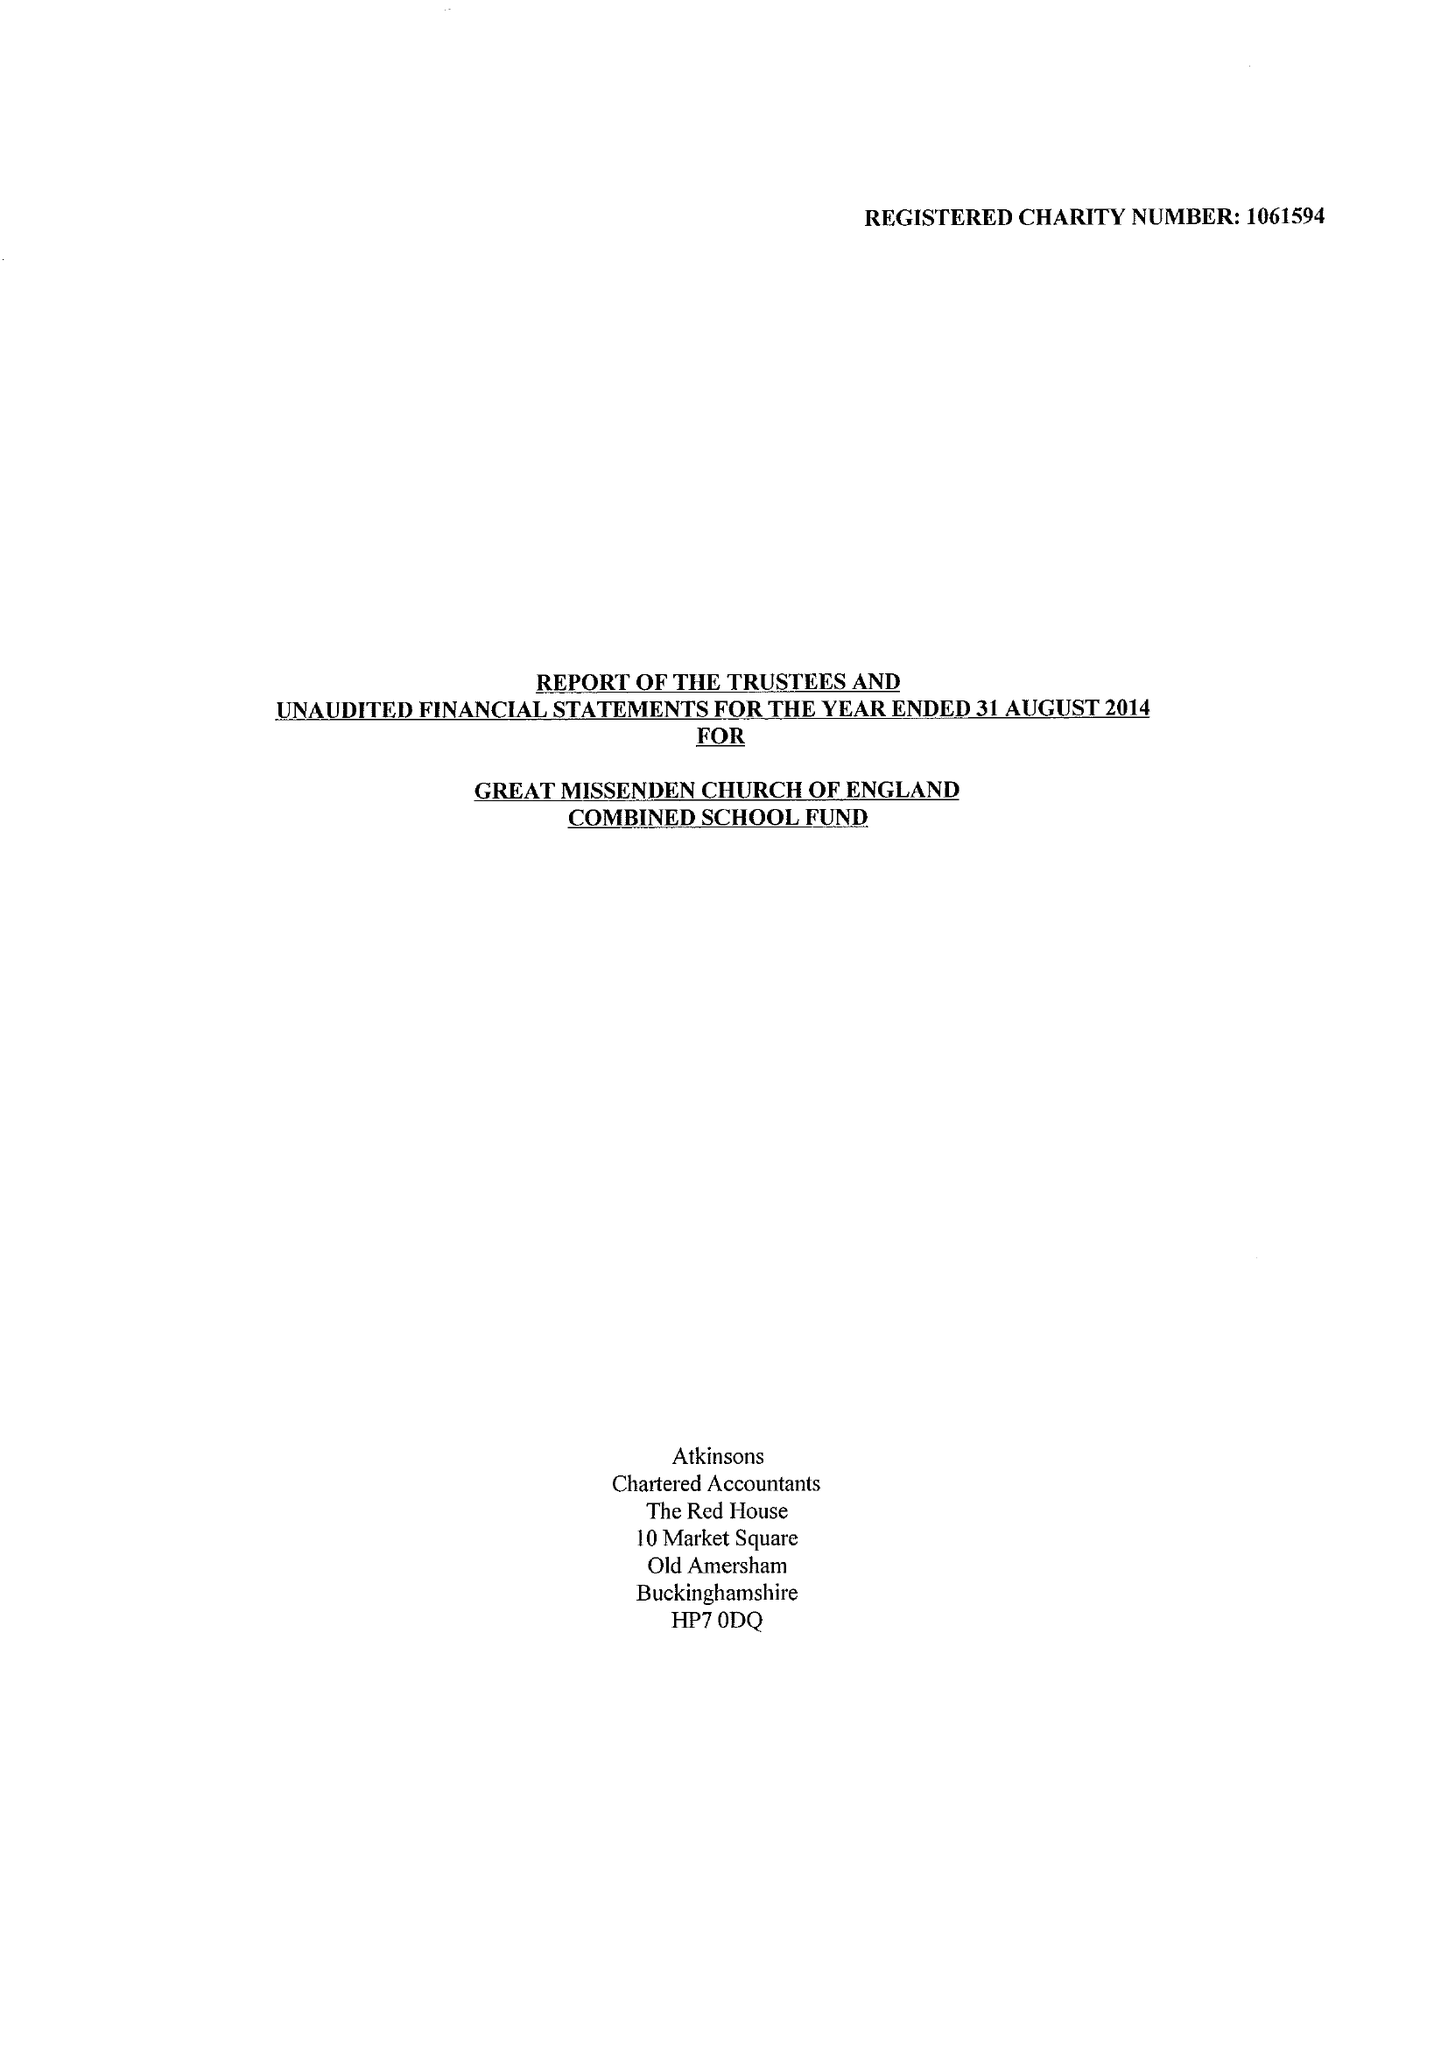What is the value for the charity_number?
Answer the question using a single word or phrase. 1061594 